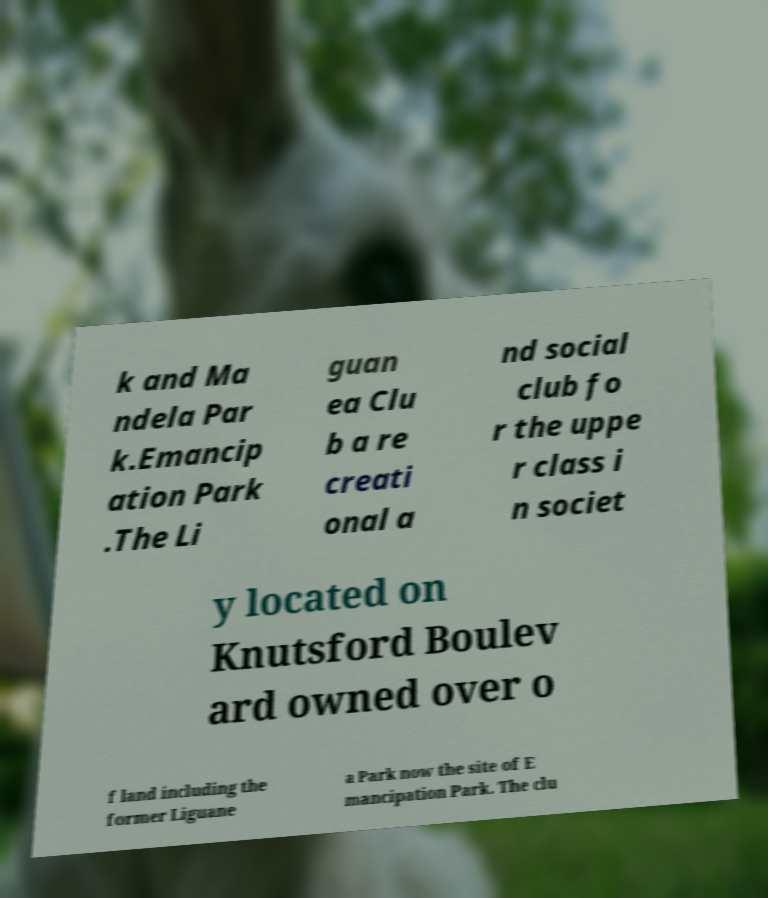Can you accurately transcribe the text from the provided image for me? k and Ma ndela Par k.Emancip ation Park .The Li guan ea Clu b a re creati onal a nd social club fo r the uppe r class i n societ y located on Knutsford Boulev ard owned over o f land including the former Liguane a Park now the site of E mancipation Park. The clu 